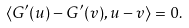Convert formula to latex. <formula><loc_0><loc_0><loc_500><loc_500>\langle G ^ { \prime } ( u ) - G ^ { \prime } ( v ) , u - v \rangle = 0 .</formula> 